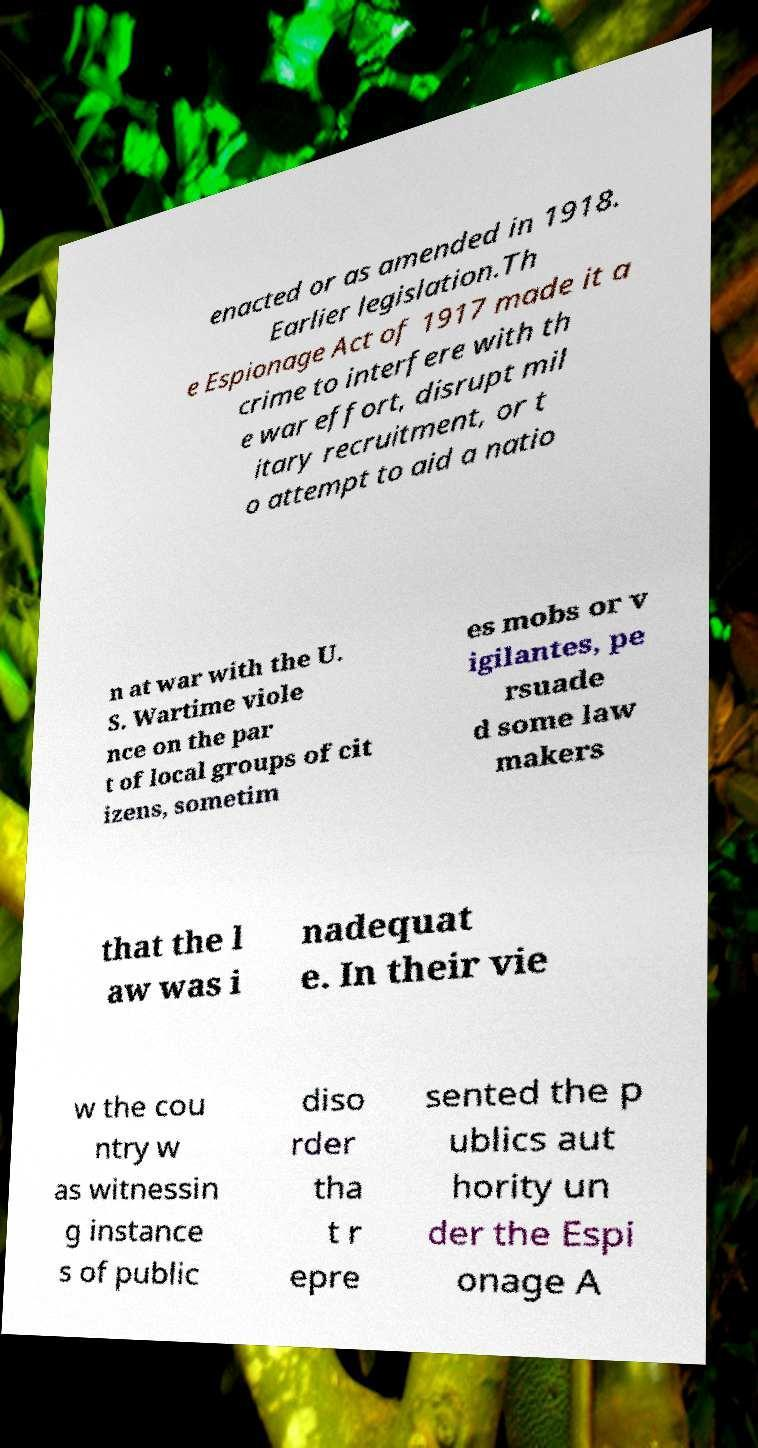For documentation purposes, I need the text within this image transcribed. Could you provide that? enacted or as amended in 1918. Earlier legislation.Th e Espionage Act of 1917 made it a crime to interfere with th e war effort, disrupt mil itary recruitment, or t o attempt to aid a natio n at war with the U. S. Wartime viole nce on the par t of local groups of cit izens, sometim es mobs or v igilantes, pe rsuade d some law makers that the l aw was i nadequat e. In their vie w the cou ntry w as witnessin g instance s of public diso rder tha t r epre sented the p ublics aut hority un der the Espi onage A 